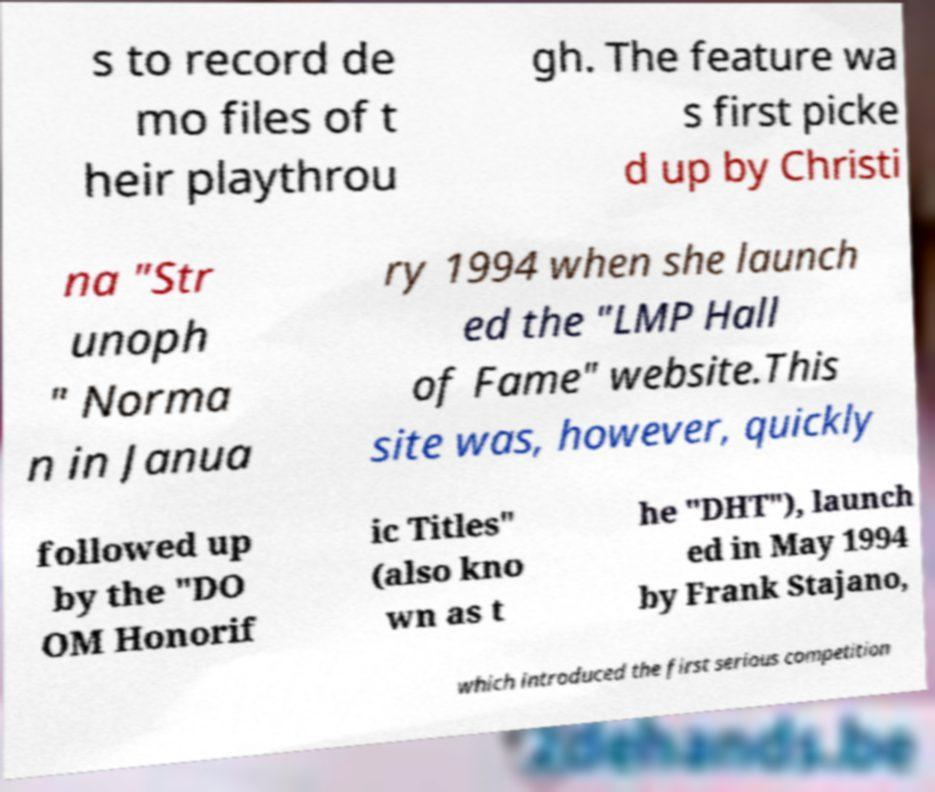Could you extract and type out the text from this image? s to record de mo files of t heir playthrou gh. The feature wa s first picke d up by Christi na "Str unoph " Norma n in Janua ry 1994 when she launch ed the "LMP Hall of Fame" website.This site was, however, quickly followed up by the "DO OM Honorif ic Titles" (also kno wn as t he "DHT"), launch ed in May 1994 by Frank Stajano, which introduced the first serious competition 